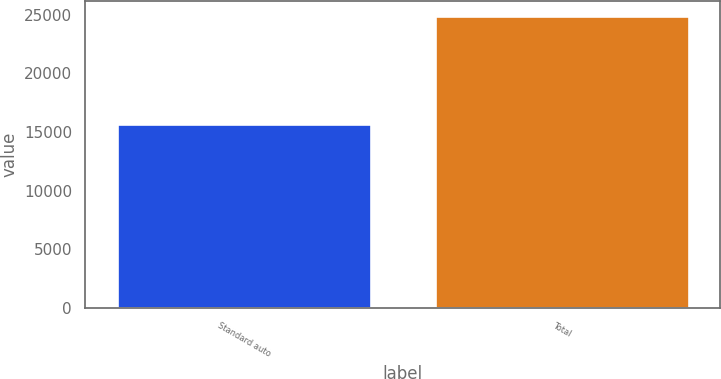Convert chart to OTSL. <chart><loc_0><loc_0><loc_500><loc_500><bar_chart><fcel>Standard auto<fcel>Total<nl><fcel>15700<fcel>24889<nl></chart> 